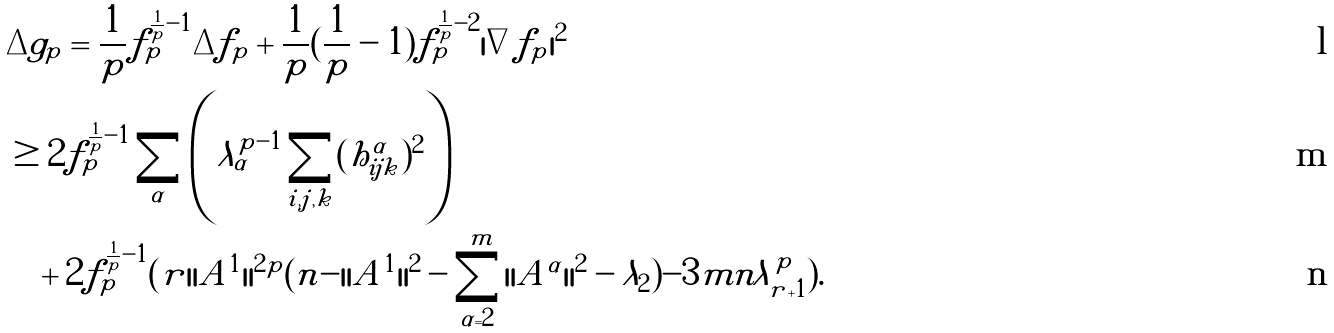<formula> <loc_0><loc_0><loc_500><loc_500>& \Delta g _ { p } = \frac { 1 } { p } f _ { p } ^ { \frac { 1 } { p } - 1 } \Delta f _ { p } + \frac { 1 } { p } ( \frac { 1 } { p } - 1 ) f _ { p } ^ { \frac { 1 } { p } - 2 } | \nabla f _ { p } | ^ { 2 } \\ & \geq 2 f _ { p } ^ { \frac { 1 } { p } - 1 } \sum _ { \alpha } \left ( \lambda _ { \alpha } ^ { p - 1 } \sum _ { i , j , k } ( h _ { i j k } ^ { \alpha } ) ^ { 2 } \right ) \\ & \quad + 2 f _ { p } ^ { \frac { 1 } { p } - 1 } ( r | | A ^ { 1 } | | ^ { 2 p } ( n - | | A ^ { 1 } | | ^ { 2 } - \sum _ { \alpha = 2 } ^ { m } | | A ^ { \alpha } | | ^ { 2 } - \lambda _ { 2 } ) - 3 m n \lambda _ { r + 1 } ^ { p } ) .</formula> 